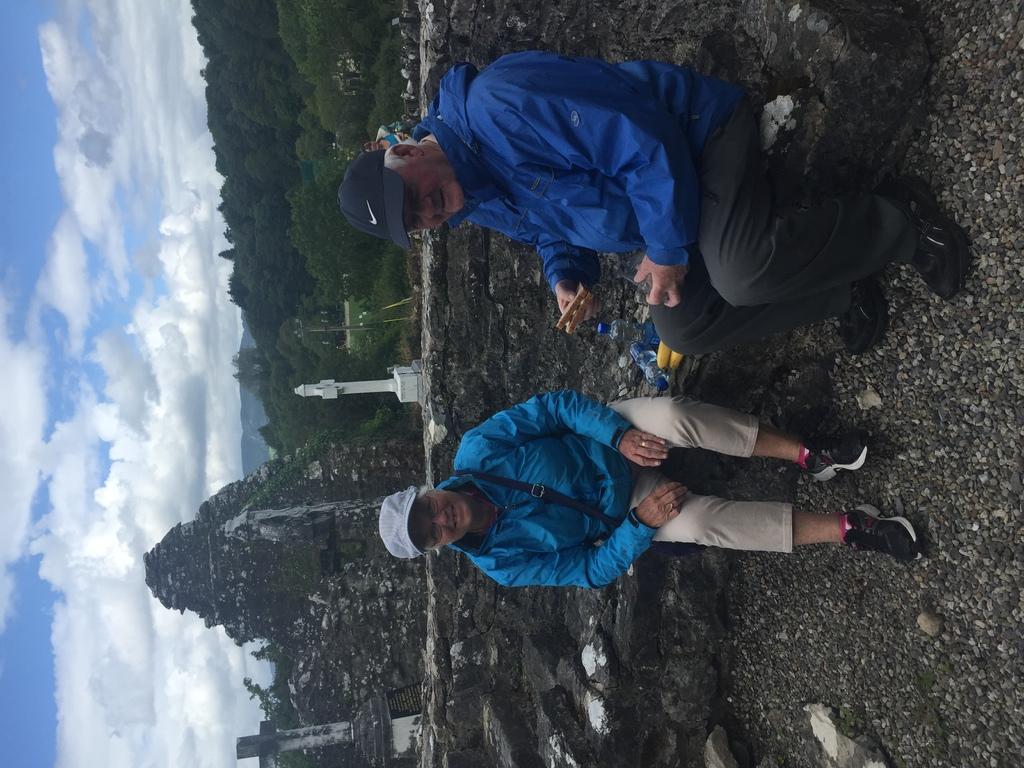Please provide a concise description of this image. In the center of the image there are persons sitting at the wall. In the background we can see pillar, hills, trees, buildings, sky and clouds. 